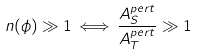<formula> <loc_0><loc_0><loc_500><loc_500>n ( \phi ) \gg 1 \, \Longleftrightarrow \, \frac { A ^ { p e r t } _ { S } } { A ^ { p e r t } _ { T } } \gg 1</formula> 